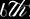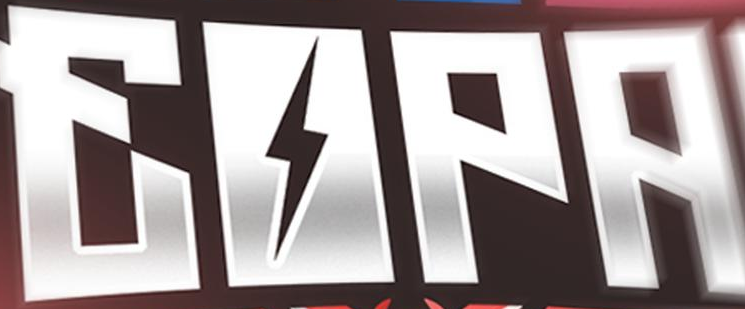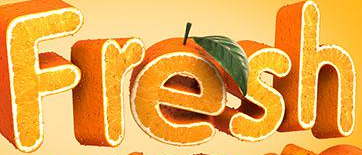What text is displayed in these images sequentially, separated by a semicolon? 6th; EOPA; Fresh 